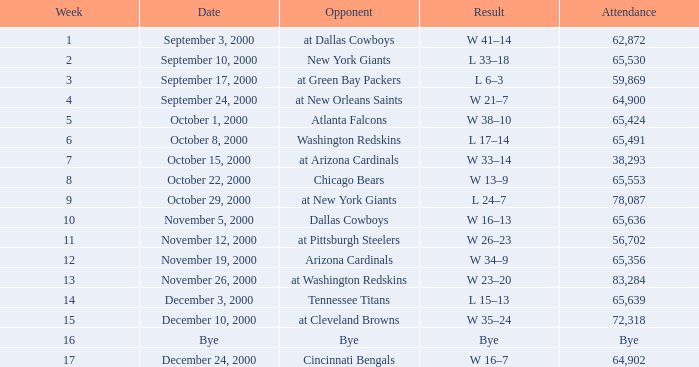What was the week 2 attendance count? 65530.0. 